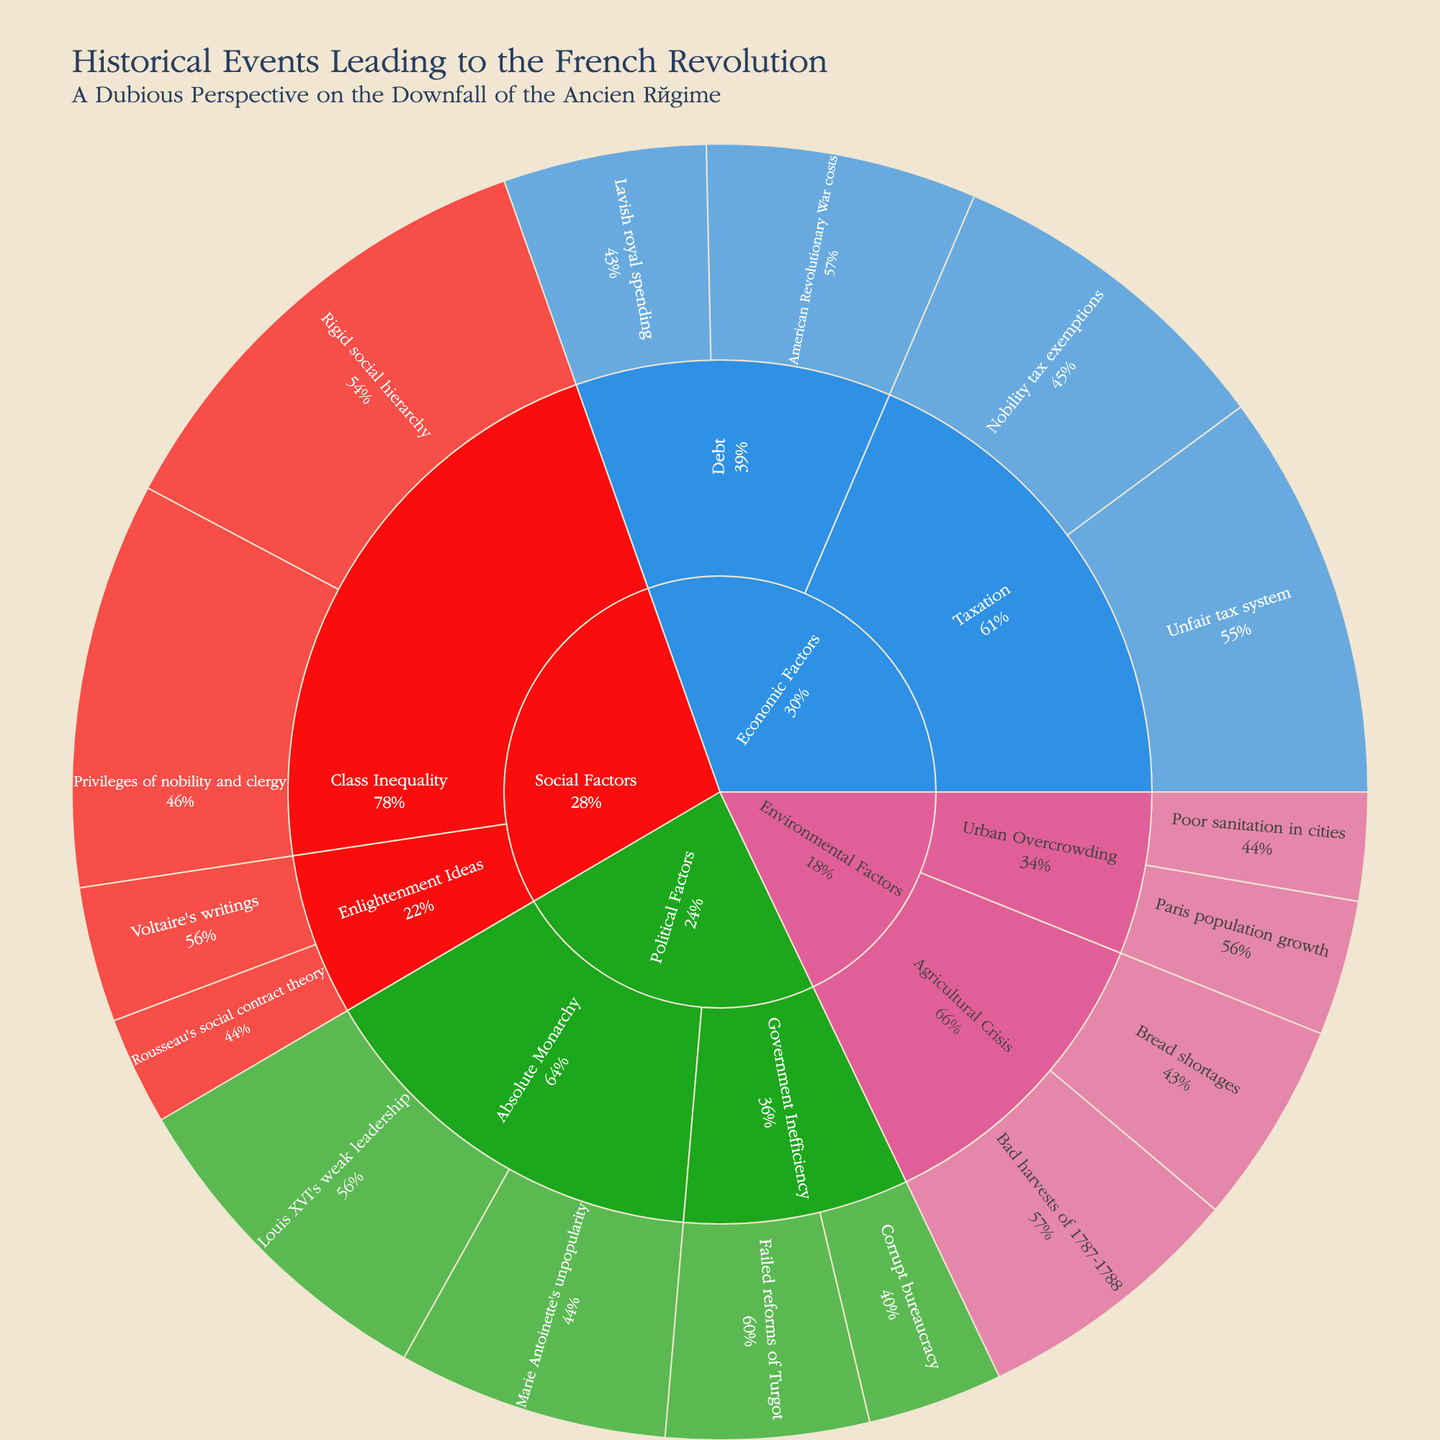What is the title of the Sunburst Plot? The title is displayed at the top of the figure and provides a summary of what the plot is about.
Answer: Historical Events Leading to the French Revolution Which category has the highest accumulated value? Observe the categories in the outermost ring and compare their total values. The category with the largest segment in terms of proportion represents the highest accumulated value.
Answer: Social Factors How many subcategories are under the Environmental Factors category? Count the distinct segments in the outer ring that are nested under the Environmental Factors category.
Answer: 2 What is the value of "Unfair tax system" event under Economic Factors? Identify the segment labeled "Unfair tax system" in the Economic Factors category, then refer to the value displayed there.
Answer: 30 Which category does the "Rigid social hierarchy" event fall under? Locate the "Rigid social hierarchy" event in the outer ring and refer to the corresponding category at the root of its branch.
Answer: Social Factors What is the total value of events under the Debt subcategory? Add the values of all events under the Debt subcategory in the Economic Factors category. The events are "American Revolutionary War costs" and "Lavish royal spending."
Answer: 35 Which subcategory under Political Factors has the largest individual event value? Compare the values of events within each subcategory under Political Factors and identify the subcategory with the largest single event value.
Answer: Absolute Monarchy What percentage of the Class Inequality subcategory is attributed to "Privileges of nobility and clergy"? Calculate the percentage by dividing the value of "Privileges of nobility and clergy" by the total value of Class Inequality and multiplying by 100.
Answer: (30/65) * 100 = ~46.15% Which event in the Sunburst Plot has the smallest value and what is its category? Locate the event with the smallest segment and note its value and category.
Answer: Poor sanitation in cities, Environmental Factors 